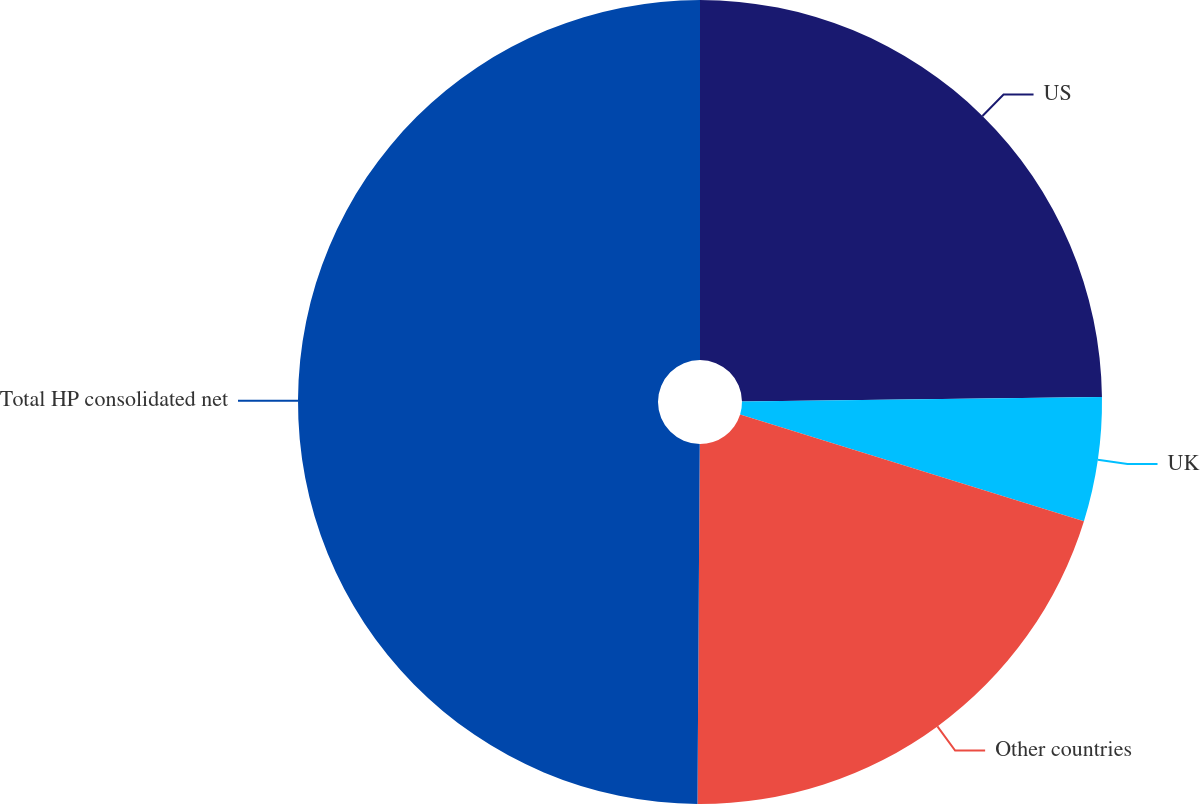Convert chart. <chart><loc_0><loc_0><loc_500><loc_500><pie_chart><fcel>US<fcel>UK<fcel>Other countries<fcel>Total HP consolidated net<nl><fcel>24.8%<fcel>4.99%<fcel>20.31%<fcel>49.9%<nl></chart> 